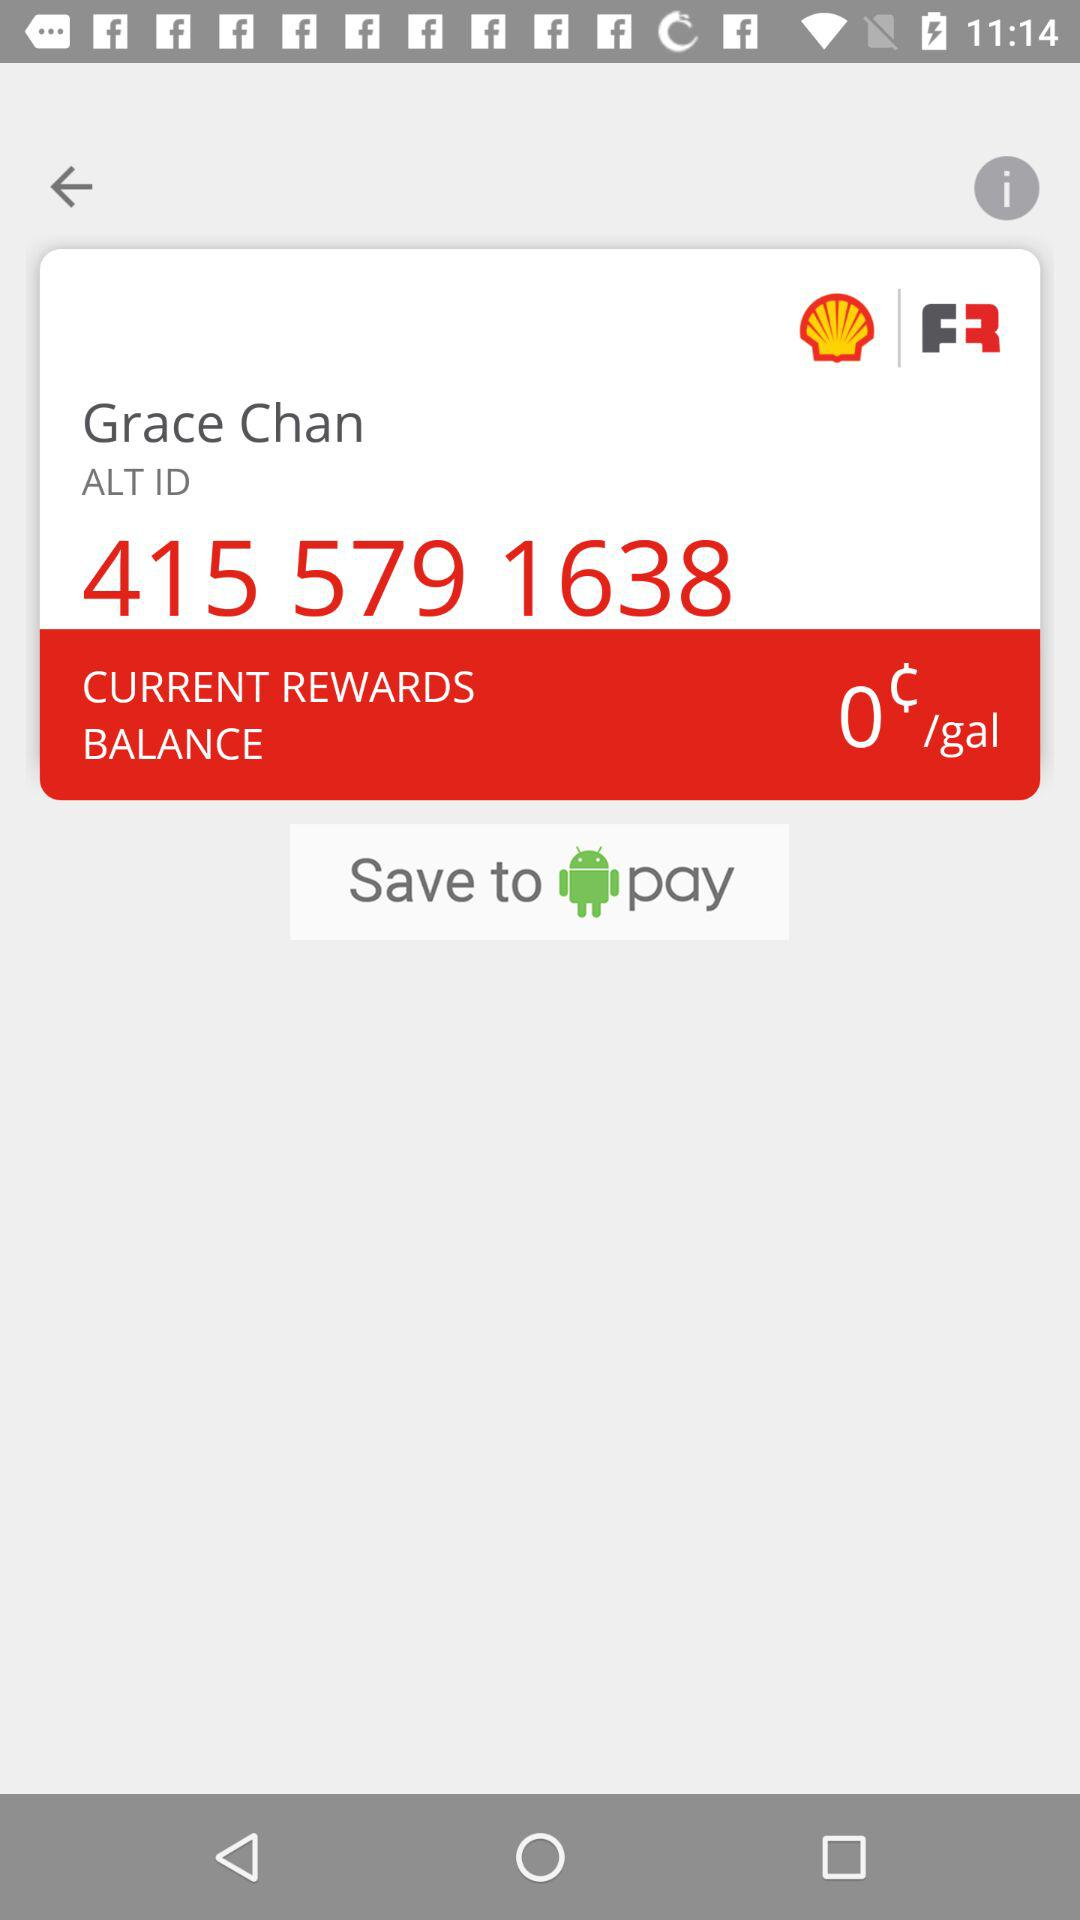What is the "CURRENT REWARDS BALANCE"? The "CURRENT REWARDS BALANCE" is 0¢/gal. 